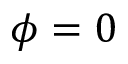Convert formula to latex. <formula><loc_0><loc_0><loc_500><loc_500>\phi = 0</formula> 